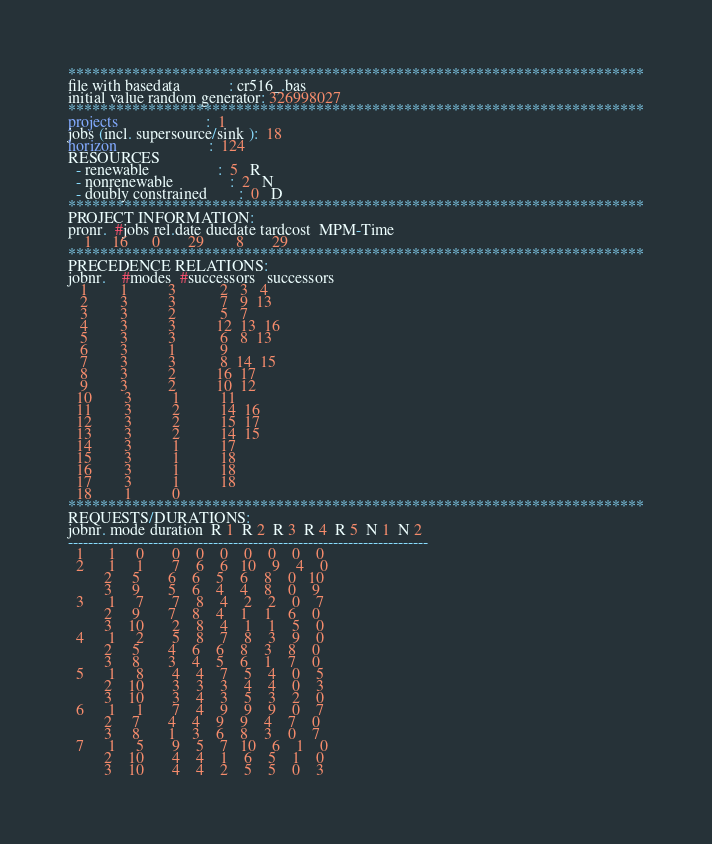<code> <loc_0><loc_0><loc_500><loc_500><_ObjectiveC_>************************************************************************
file with basedata            : cr516_.bas
initial value random generator: 326998027
************************************************************************
projects                      :  1
jobs (incl. supersource/sink ):  18
horizon                       :  124
RESOURCES
  - renewable                 :  5   R
  - nonrenewable              :  2   N
  - doubly constrained        :  0   D
************************************************************************
PROJECT INFORMATION:
pronr.  #jobs rel.date duedate tardcost  MPM-Time
    1     16      0       29        8       29
************************************************************************
PRECEDENCE RELATIONS:
jobnr.    #modes  #successors   successors
   1        1          3           2   3   4
   2        3          3           7   9  13
   3        3          2           5   7
   4        3          3          12  13  16
   5        3          3           6   8  13
   6        3          1           9
   7        3          3           8  14  15
   8        3          2          16  17
   9        3          2          10  12
  10        3          1          11
  11        3          2          14  16
  12        3          2          15  17
  13        3          2          14  15
  14        3          1          17
  15        3          1          18
  16        3          1          18
  17        3          1          18
  18        1          0        
************************************************************************
REQUESTS/DURATIONS:
jobnr. mode duration  R 1  R 2  R 3  R 4  R 5  N 1  N 2
------------------------------------------------------------------------
  1      1     0       0    0    0    0    0    0    0
  2      1     1       7    6    6   10    9    4    0
         2     5       6    6    5    6    8    0   10
         3     9       5    6    4    4    8    0    9
  3      1     7       7    8    4    2    2    0    7
         2     9       7    8    4    1    1    6    0
         3    10       2    8    4    1    1    5    0
  4      1     2       5    8    7    8    3    9    0
         2     5       4    6    6    8    3    8    0
         3     8       3    4    5    6    1    7    0
  5      1     8       4    4    7    5    4    0    5
         2    10       3    3    3    4    4    0    3
         3    10       3    4    3    5    3    2    0
  6      1     1       7    4    9    9    9    0    7
         2     7       4    4    9    9    4    7    0
         3     8       1    3    6    8    3    0    7
  7      1     5       9    5    7   10    6    1    0
         2    10       4    4    1    6    5    1    0
         3    10       4    4    2    5    5    0    3</code> 